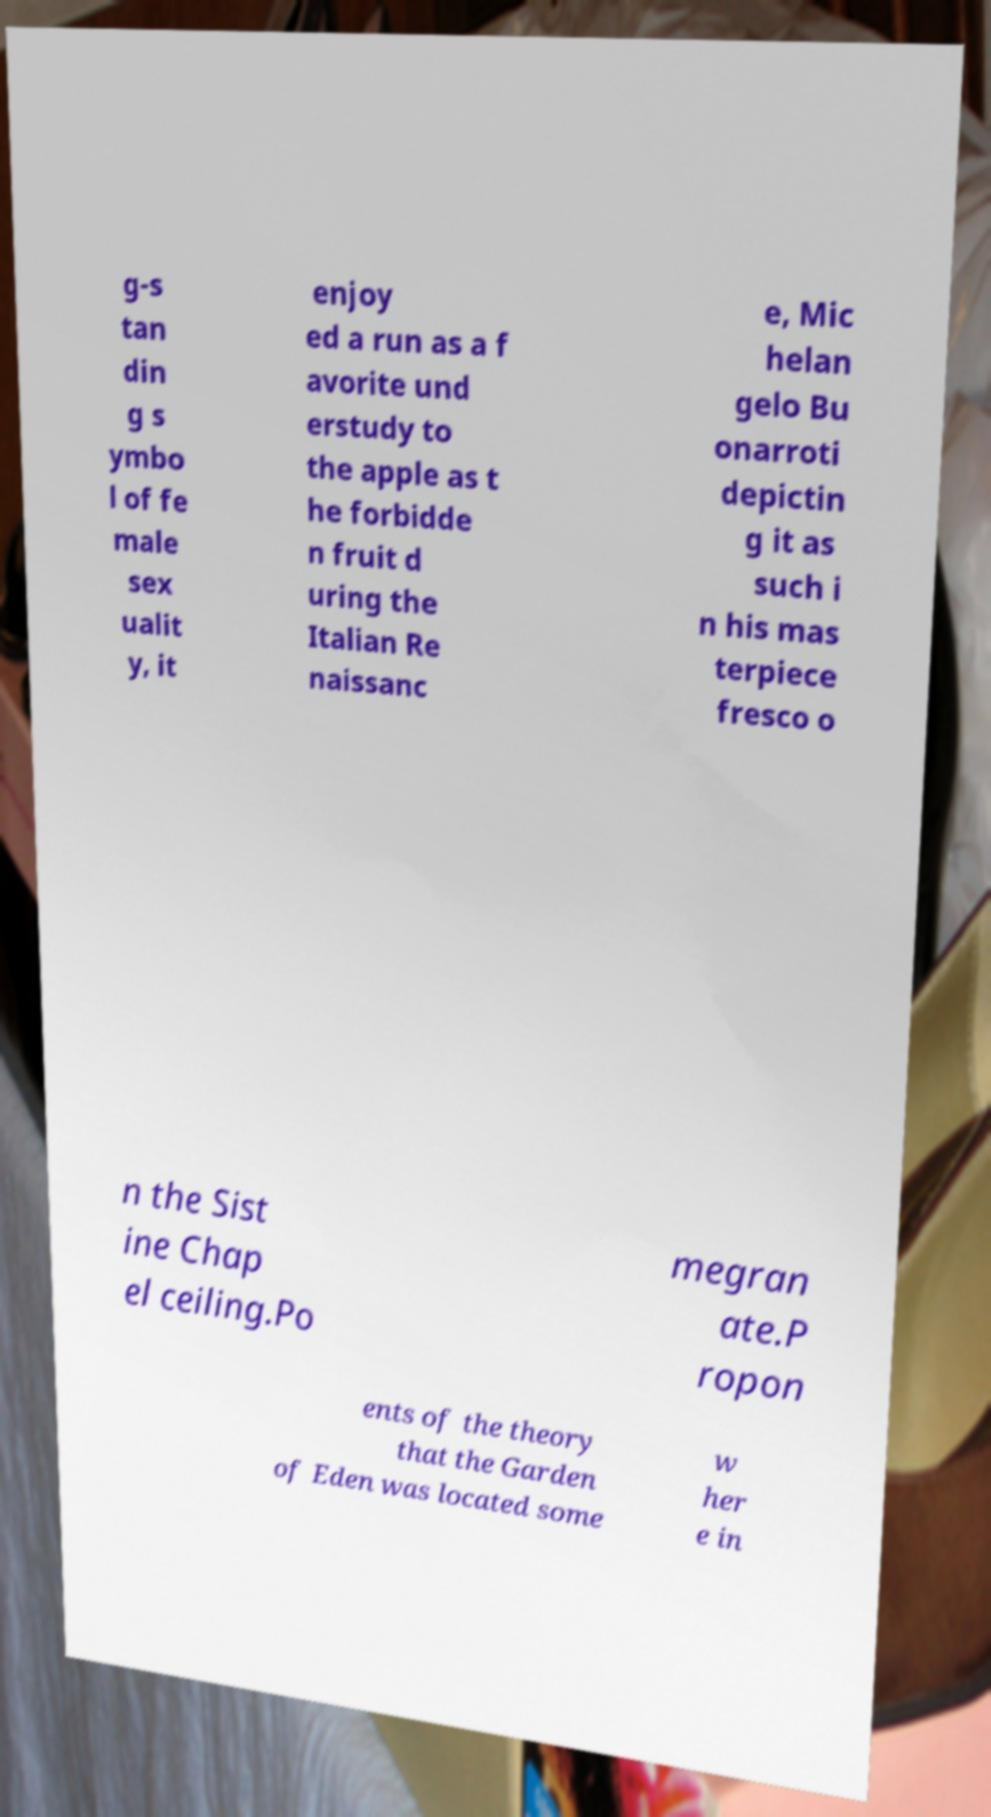What messages or text are displayed in this image? I need them in a readable, typed format. g-s tan din g s ymbo l of fe male sex ualit y, it enjoy ed a run as a f avorite und erstudy to the apple as t he forbidde n fruit d uring the Italian Re naissanc e, Mic helan gelo Bu onarroti depictin g it as such i n his mas terpiece fresco o n the Sist ine Chap el ceiling.Po megran ate.P ropon ents of the theory that the Garden of Eden was located some w her e in 